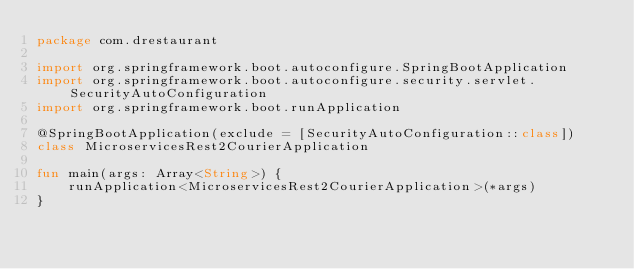Convert code to text. <code><loc_0><loc_0><loc_500><loc_500><_Kotlin_>package com.drestaurant

import org.springframework.boot.autoconfigure.SpringBootApplication
import org.springframework.boot.autoconfigure.security.servlet.SecurityAutoConfiguration
import org.springframework.boot.runApplication

@SpringBootApplication(exclude = [SecurityAutoConfiguration::class])
class MicroservicesRest2CourierApplication

fun main(args: Array<String>) {
    runApplication<MicroservicesRest2CourierApplication>(*args)
}
</code> 